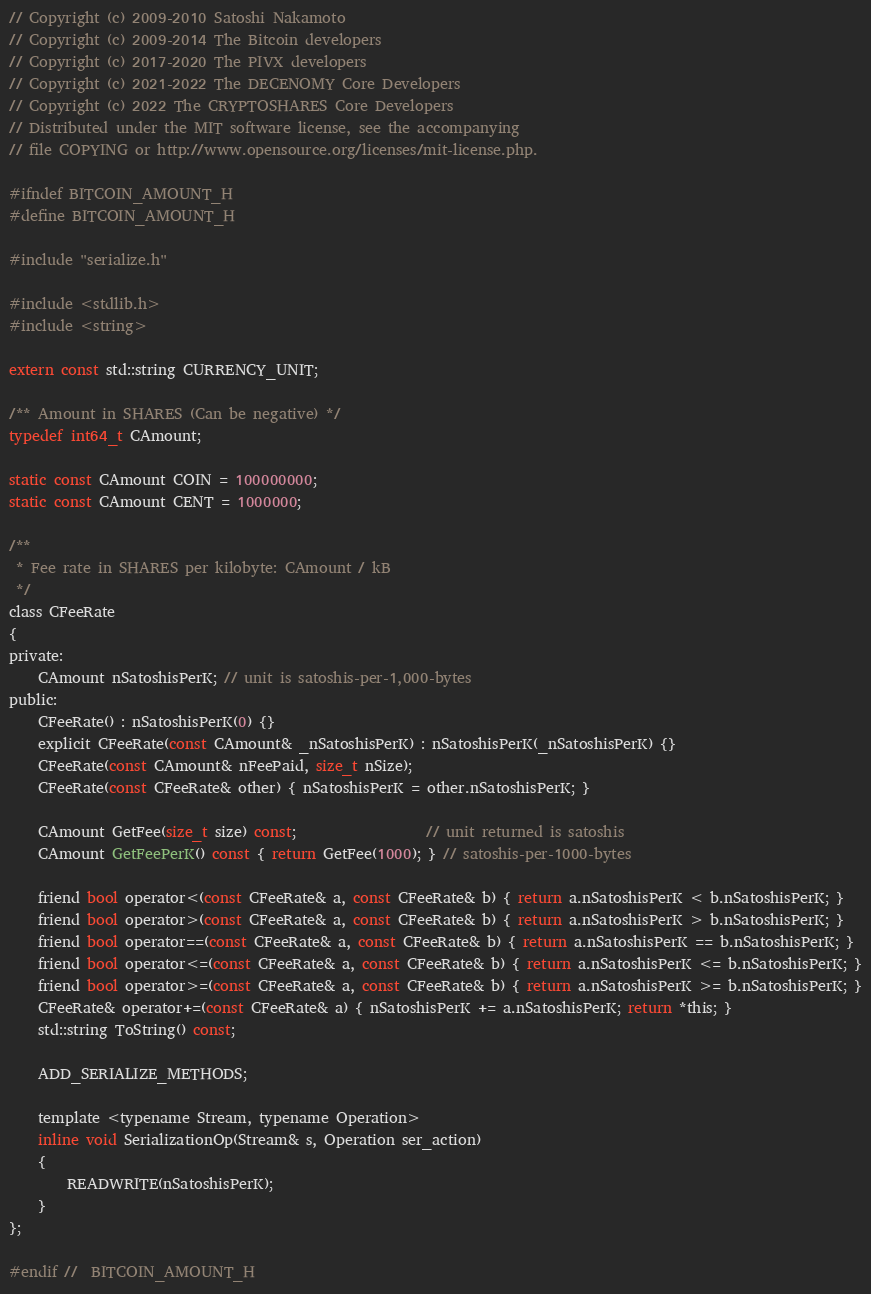<code> <loc_0><loc_0><loc_500><loc_500><_C_>// Copyright (c) 2009-2010 Satoshi Nakamoto
// Copyright (c) 2009-2014 The Bitcoin developers
// Copyright (c) 2017-2020 The PIVX developers
// Copyright (c) 2021-2022 The DECENOMY Core Developers
// Copyright (c) 2022 The CRYPTOSHARES Core Developers
// Distributed under the MIT software license, see the accompanying
// file COPYING or http://www.opensource.org/licenses/mit-license.php.

#ifndef BITCOIN_AMOUNT_H
#define BITCOIN_AMOUNT_H

#include "serialize.h"

#include <stdlib.h>
#include <string>

extern const std::string CURRENCY_UNIT;

/** Amount in SHARES (Can be negative) */
typedef int64_t CAmount;

static const CAmount COIN = 100000000;
static const CAmount CENT = 1000000;

/**
 * Fee rate in SHARES per kilobyte: CAmount / kB
 */
class CFeeRate
{
private:
    CAmount nSatoshisPerK; // unit is satoshis-per-1,000-bytes
public:
    CFeeRate() : nSatoshisPerK(0) {}
    explicit CFeeRate(const CAmount& _nSatoshisPerK) : nSatoshisPerK(_nSatoshisPerK) {}
    CFeeRate(const CAmount& nFeePaid, size_t nSize);
    CFeeRate(const CFeeRate& other) { nSatoshisPerK = other.nSatoshisPerK; }

    CAmount GetFee(size_t size) const;                  // unit returned is satoshis
    CAmount GetFeePerK() const { return GetFee(1000); } // satoshis-per-1000-bytes

    friend bool operator<(const CFeeRate& a, const CFeeRate& b) { return a.nSatoshisPerK < b.nSatoshisPerK; }
    friend bool operator>(const CFeeRate& a, const CFeeRate& b) { return a.nSatoshisPerK > b.nSatoshisPerK; }
    friend bool operator==(const CFeeRate& a, const CFeeRate& b) { return a.nSatoshisPerK == b.nSatoshisPerK; }
    friend bool operator<=(const CFeeRate& a, const CFeeRate& b) { return a.nSatoshisPerK <= b.nSatoshisPerK; }
    friend bool operator>=(const CFeeRate& a, const CFeeRate& b) { return a.nSatoshisPerK >= b.nSatoshisPerK; }
    CFeeRate& operator+=(const CFeeRate& a) { nSatoshisPerK += a.nSatoshisPerK; return *this; }
    std::string ToString() const;

    ADD_SERIALIZE_METHODS;

    template <typename Stream, typename Operation>
    inline void SerializationOp(Stream& s, Operation ser_action)
    {
        READWRITE(nSatoshisPerK);
    }
};

#endif //  BITCOIN_AMOUNT_H
</code> 